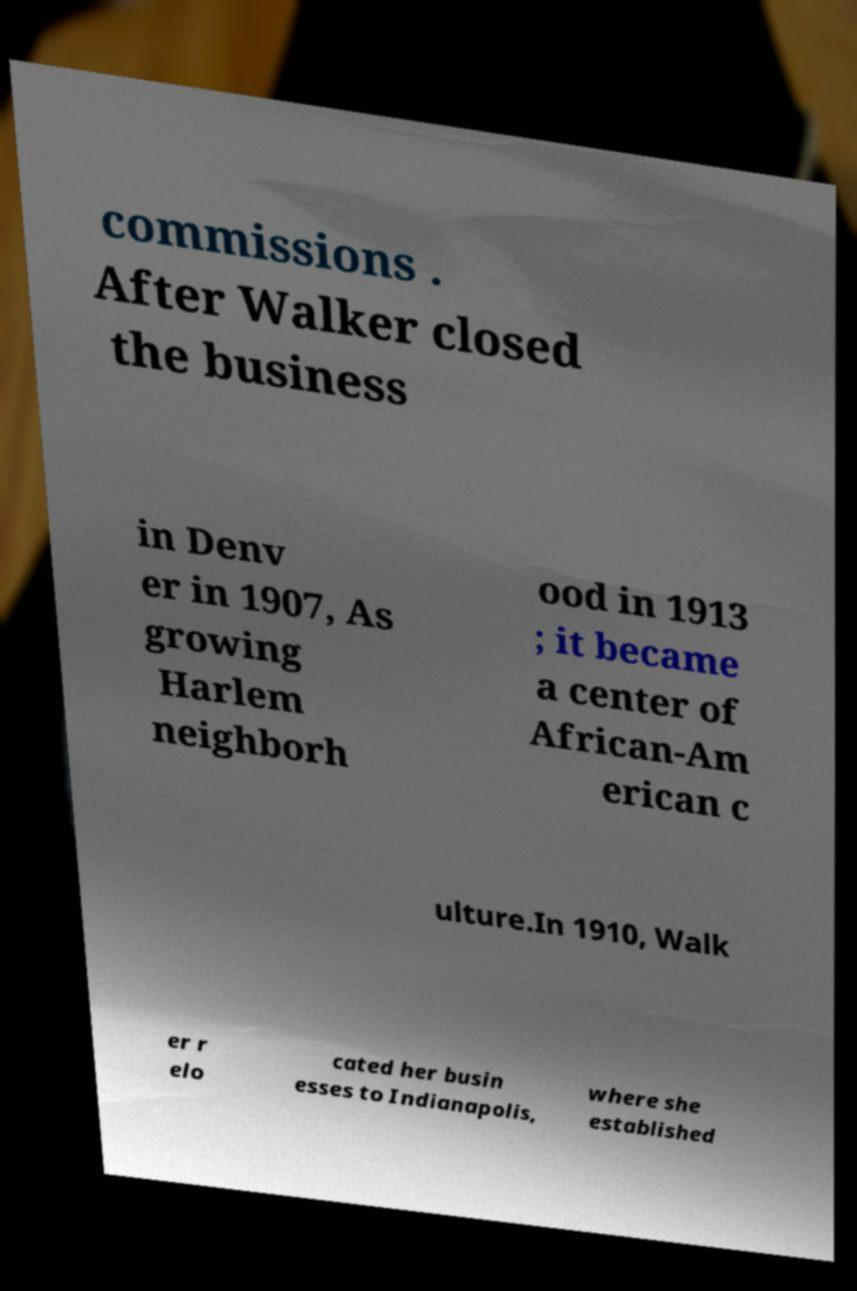Could you extract and type out the text from this image? commissions . After Walker closed the business in Denv er in 1907, As growing Harlem neighborh ood in 1913 ; it became a center of African-Am erican c ulture.In 1910, Walk er r elo cated her busin esses to Indianapolis, where she established 